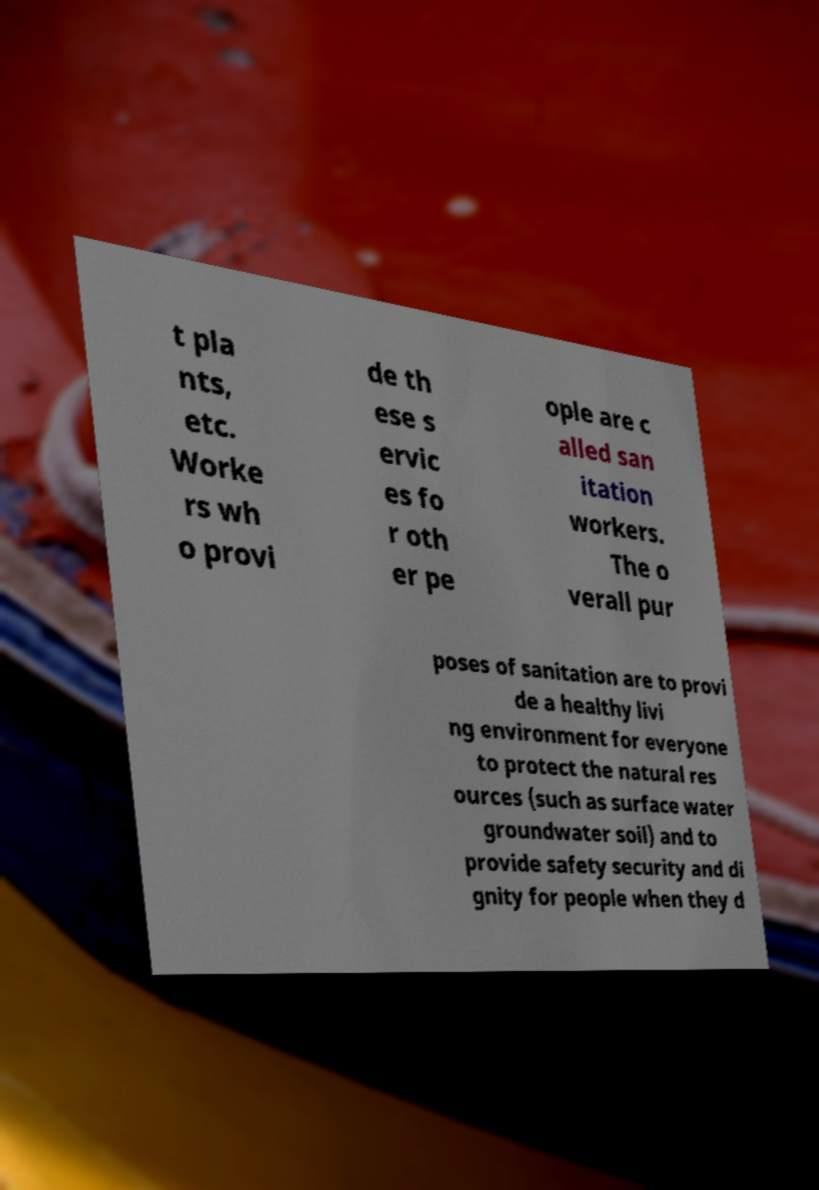Could you extract and type out the text from this image? t pla nts, etc. Worke rs wh o provi de th ese s ervic es fo r oth er pe ople are c alled san itation workers. The o verall pur poses of sanitation are to provi de a healthy livi ng environment for everyone to protect the natural res ources (such as surface water groundwater soil) and to provide safety security and di gnity for people when they d 